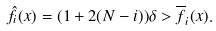Convert formula to latex. <formula><loc_0><loc_0><loc_500><loc_500>\hat { f } _ { i } ( x ) = ( 1 + 2 ( N - i ) ) \delta > \overline { f } _ { i } ( x ) .</formula> 